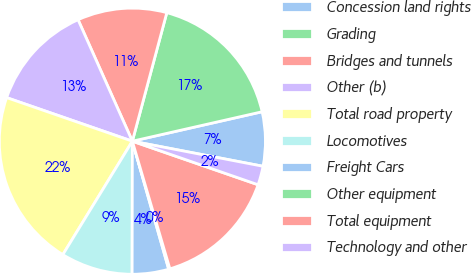Convert chart to OTSL. <chart><loc_0><loc_0><loc_500><loc_500><pie_chart><fcel>Concession land rights<fcel>Grading<fcel>Bridges and tunnels<fcel>Other (b)<fcel>Total road property<fcel>Locomotives<fcel>Freight Cars<fcel>Other equipment<fcel>Total equipment<fcel>Technology and other<nl><fcel>6.57%<fcel>17.28%<fcel>10.86%<fcel>13.0%<fcel>21.56%<fcel>8.72%<fcel>4.43%<fcel>0.15%<fcel>15.14%<fcel>2.29%<nl></chart> 